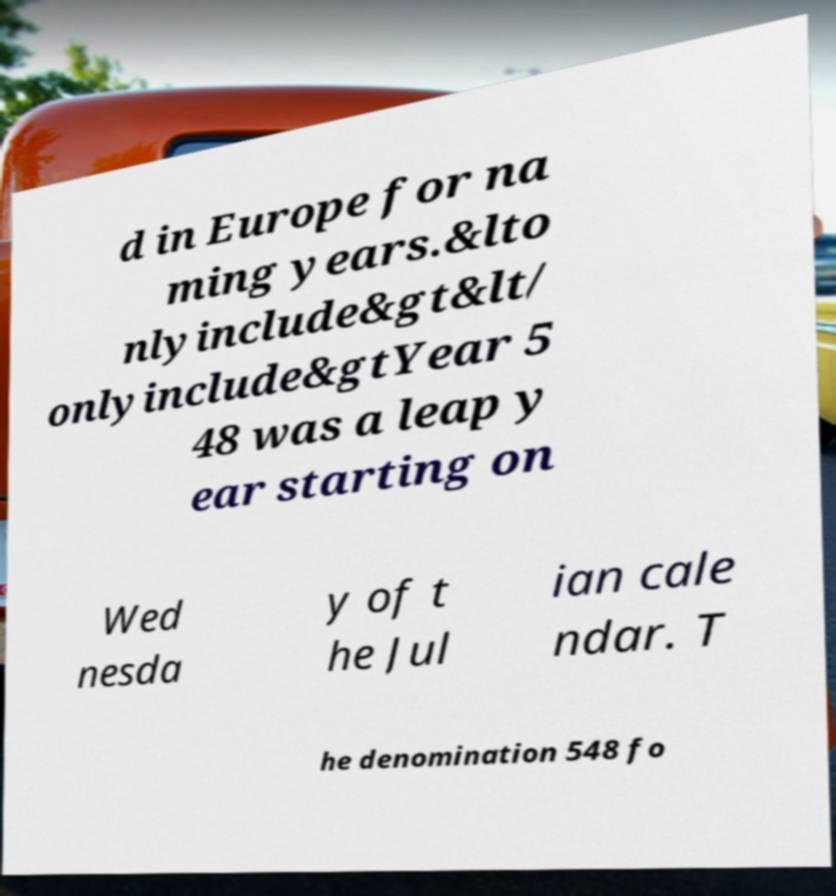Can you accurately transcribe the text from the provided image for me? d in Europe for na ming years.&lto nlyinclude&gt&lt/ onlyinclude&gtYear 5 48 was a leap y ear starting on Wed nesda y of t he Jul ian cale ndar. T he denomination 548 fo 